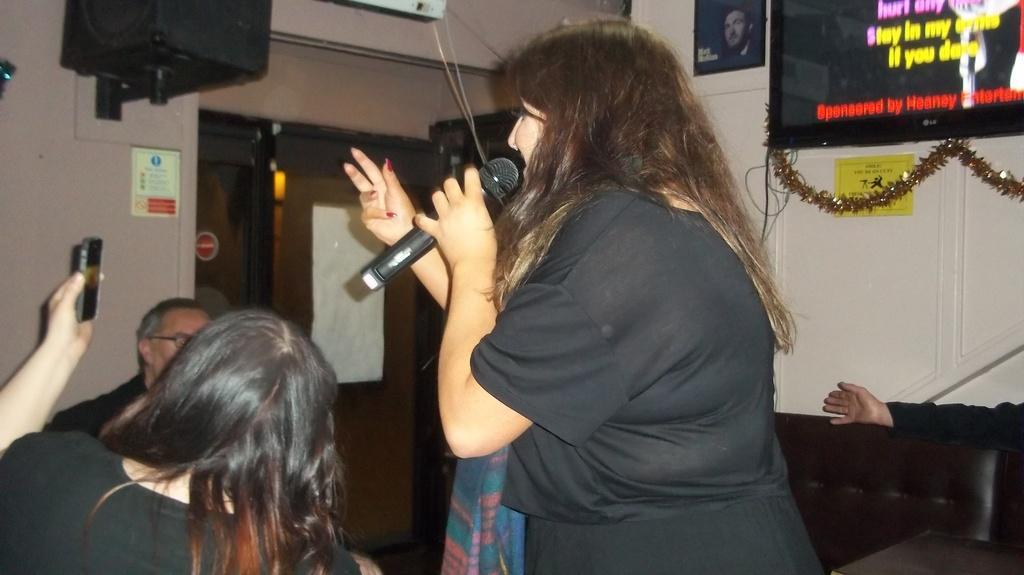Please provide a concise description of this image. There are three people in a room. On the right side we have a woman. She is holding a mic. On the right side we have a another woman. She is holding a mobile. We can see the background TV,curtain,photo frame and sound box. 